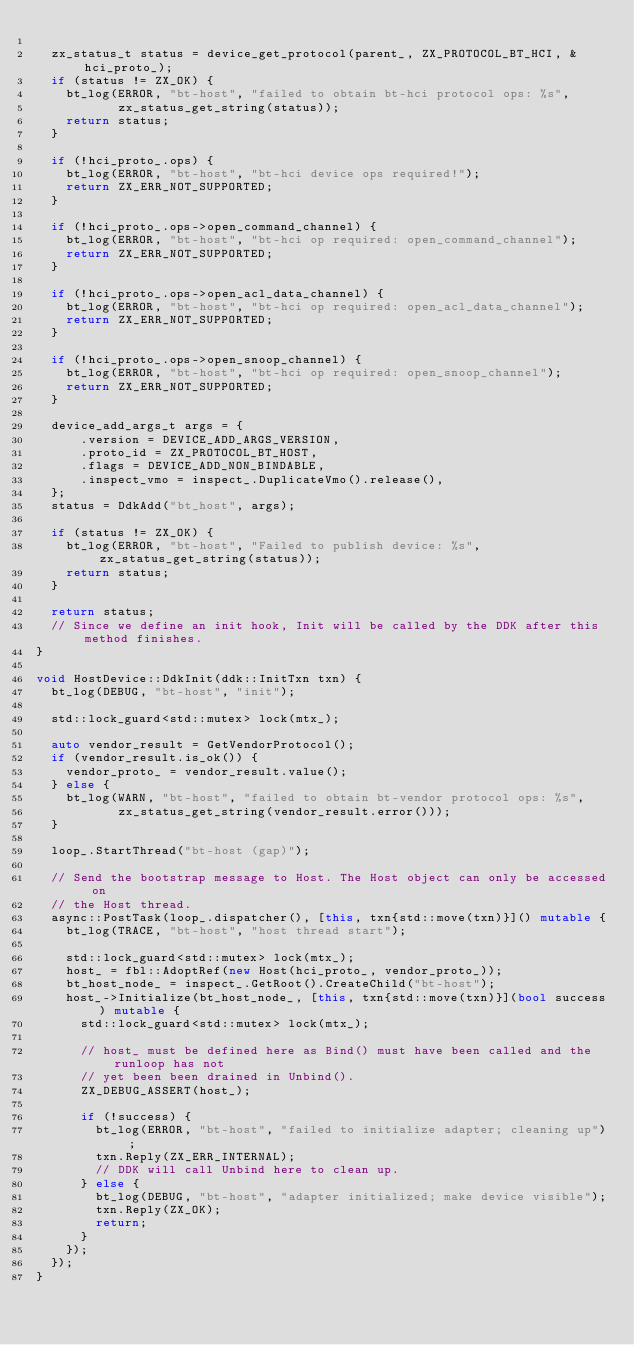Convert code to text. <code><loc_0><loc_0><loc_500><loc_500><_C++_>
  zx_status_t status = device_get_protocol(parent_, ZX_PROTOCOL_BT_HCI, &hci_proto_);
  if (status != ZX_OK) {
    bt_log(ERROR, "bt-host", "failed to obtain bt-hci protocol ops: %s",
           zx_status_get_string(status));
    return status;
  }

  if (!hci_proto_.ops) {
    bt_log(ERROR, "bt-host", "bt-hci device ops required!");
    return ZX_ERR_NOT_SUPPORTED;
  }

  if (!hci_proto_.ops->open_command_channel) {
    bt_log(ERROR, "bt-host", "bt-hci op required: open_command_channel");
    return ZX_ERR_NOT_SUPPORTED;
  }

  if (!hci_proto_.ops->open_acl_data_channel) {
    bt_log(ERROR, "bt-host", "bt-hci op required: open_acl_data_channel");
    return ZX_ERR_NOT_SUPPORTED;
  }

  if (!hci_proto_.ops->open_snoop_channel) {
    bt_log(ERROR, "bt-host", "bt-hci op required: open_snoop_channel");
    return ZX_ERR_NOT_SUPPORTED;
  }

  device_add_args_t args = {
      .version = DEVICE_ADD_ARGS_VERSION,
      .proto_id = ZX_PROTOCOL_BT_HOST,
      .flags = DEVICE_ADD_NON_BINDABLE,
      .inspect_vmo = inspect_.DuplicateVmo().release(),
  };
  status = DdkAdd("bt_host", args);

  if (status != ZX_OK) {
    bt_log(ERROR, "bt-host", "Failed to publish device: %s", zx_status_get_string(status));
    return status;
  }

  return status;
  // Since we define an init hook, Init will be called by the DDK after this method finishes.
}

void HostDevice::DdkInit(ddk::InitTxn txn) {
  bt_log(DEBUG, "bt-host", "init");

  std::lock_guard<std::mutex> lock(mtx_);

  auto vendor_result = GetVendorProtocol();
  if (vendor_result.is_ok()) {
    vendor_proto_ = vendor_result.value();
  } else {
    bt_log(WARN, "bt-host", "failed to obtain bt-vendor protocol ops: %s",
           zx_status_get_string(vendor_result.error()));
  }

  loop_.StartThread("bt-host (gap)");

  // Send the bootstrap message to Host. The Host object can only be accessed on
  // the Host thread.
  async::PostTask(loop_.dispatcher(), [this, txn{std::move(txn)}]() mutable {
    bt_log(TRACE, "bt-host", "host thread start");

    std::lock_guard<std::mutex> lock(mtx_);
    host_ = fbl::AdoptRef(new Host(hci_proto_, vendor_proto_));
    bt_host_node_ = inspect_.GetRoot().CreateChild("bt-host");
    host_->Initialize(bt_host_node_, [this, txn{std::move(txn)}](bool success) mutable {
      std::lock_guard<std::mutex> lock(mtx_);

      // host_ must be defined here as Bind() must have been called and the runloop has not
      // yet been been drained in Unbind().
      ZX_DEBUG_ASSERT(host_);

      if (!success) {
        bt_log(ERROR, "bt-host", "failed to initialize adapter; cleaning up");
        txn.Reply(ZX_ERR_INTERNAL);
        // DDK will call Unbind here to clean up.
      } else {
        bt_log(DEBUG, "bt-host", "adapter initialized; make device visible");
        txn.Reply(ZX_OK);
        return;
      }
    });
  });
}
</code> 